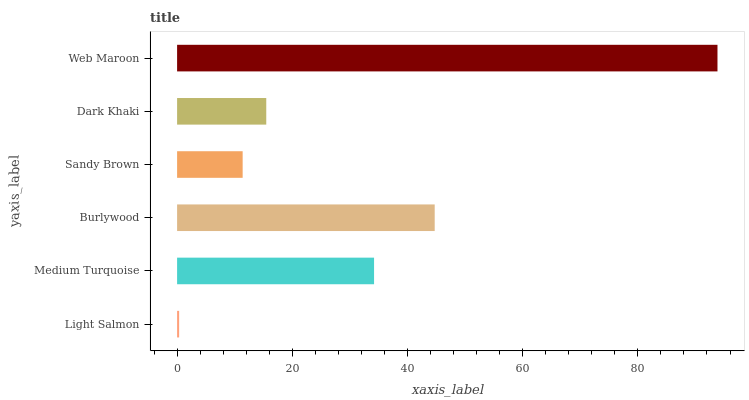Is Light Salmon the minimum?
Answer yes or no. Yes. Is Web Maroon the maximum?
Answer yes or no. Yes. Is Medium Turquoise the minimum?
Answer yes or no. No. Is Medium Turquoise the maximum?
Answer yes or no. No. Is Medium Turquoise greater than Light Salmon?
Answer yes or no. Yes. Is Light Salmon less than Medium Turquoise?
Answer yes or no. Yes. Is Light Salmon greater than Medium Turquoise?
Answer yes or no. No. Is Medium Turquoise less than Light Salmon?
Answer yes or no. No. Is Medium Turquoise the high median?
Answer yes or no. Yes. Is Dark Khaki the low median?
Answer yes or no. Yes. Is Sandy Brown the high median?
Answer yes or no. No. Is Burlywood the low median?
Answer yes or no. No. 